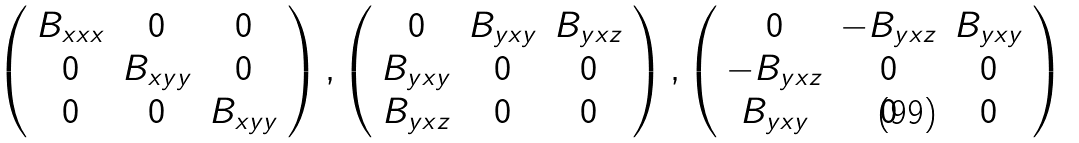<formula> <loc_0><loc_0><loc_500><loc_500>\left ( \begin{array} { c c c } B _ { x x x } & 0 & 0 \\ 0 & B _ { x y y } & 0 \\ 0 & 0 & B _ { x y y } \end{array} \right ) , \left ( \begin{array} { c c c } 0 & B _ { y x y } & B _ { y x z } \\ B _ { y x y } & 0 & 0 \\ B _ { y x z } & 0 & 0 \end{array} \right ) , \left ( \begin{array} { c c c } 0 & - B _ { y x z } & B _ { y x y } \\ - B _ { y x z } & 0 & 0 \\ B _ { y x y } & 0 & 0 \end{array} \right )</formula> 